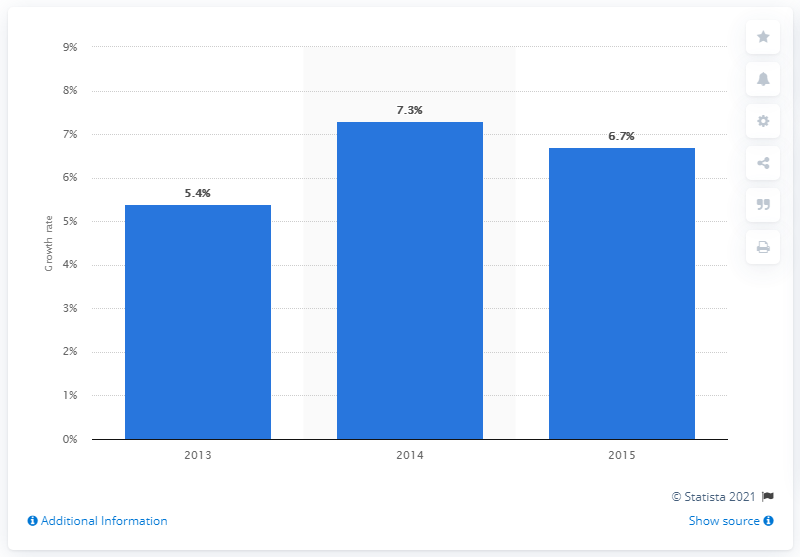Draw attention to some important aspects in this diagram. The global market for NC software and related services grew by 5.4 percent in 2013 compared to 2012. 